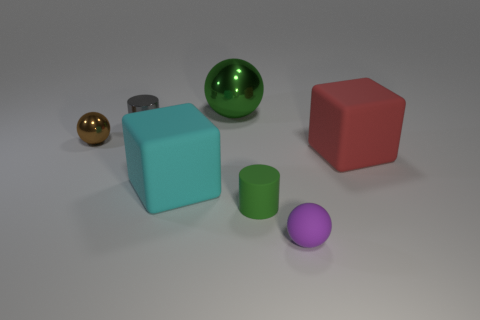Add 2 metallic things. How many objects exist? 9 Subtract all spheres. How many objects are left? 4 Subtract all small rubber cylinders. Subtract all large cyan objects. How many objects are left? 5 Add 1 small rubber balls. How many small rubber balls are left? 2 Add 2 small cylinders. How many small cylinders exist? 4 Subtract 0 yellow cubes. How many objects are left? 7 